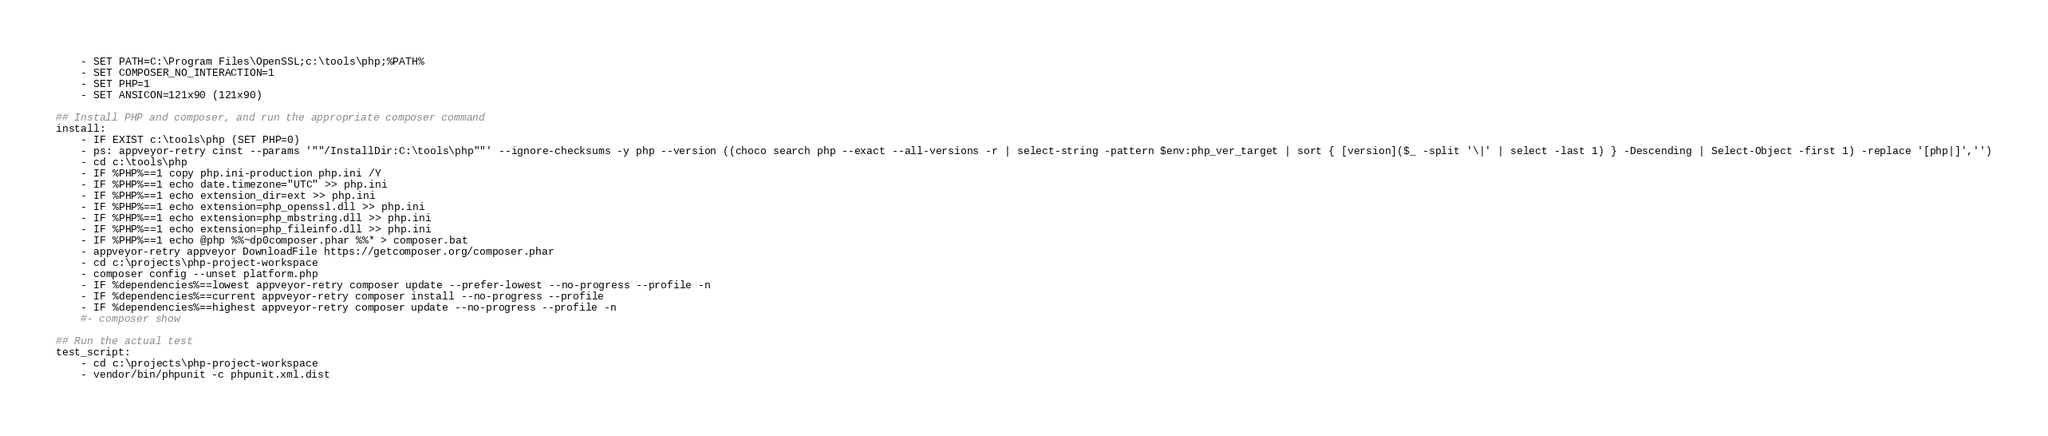Convert code to text. <code><loc_0><loc_0><loc_500><loc_500><_YAML_>    - SET PATH=C:\Program Files\OpenSSL;c:\tools\php;%PATH%
    - SET COMPOSER_NO_INTERACTION=1
    - SET PHP=1
    - SET ANSICON=121x90 (121x90)

## Install PHP and composer, and run the appropriate composer command
install:
    - IF EXIST c:\tools\php (SET PHP=0)
    - ps: appveyor-retry cinst --params '""/InstallDir:C:\tools\php""' --ignore-checksums -y php --version ((choco search php --exact --all-versions -r | select-string -pattern $env:php_ver_target | sort { [version]($_ -split '\|' | select -last 1) } -Descending | Select-Object -first 1) -replace '[php|]','')
    - cd c:\tools\php
    - IF %PHP%==1 copy php.ini-production php.ini /Y
    - IF %PHP%==1 echo date.timezone="UTC" >> php.ini
    - IF %PHP%==1 echo extension_dir=ext >> php.ini
    - IF %PHP%==1 echo extension=php_openssl.dll >> php.ini
    - IF %PHP%==1 echo extension=php_mbstring.dll >> php.ini
    - IF %PHP%==1 echo extension=php_fileinfo.dll >> php.ini
    - IF %PHP%==1 echo @php %%~dp0composer.phar %%* > composer.bat
    - appveyor-retry appveyor DownloadFile https://getcomposer.org/composer.phar
    - cd c:\projects\php-project-workspace
    - composer config --unset platform.php
    - IF %dependencies%==lowest appveyor-retry composer update --prefer-lowest --no-progress --profile -n
    - IF %dependencies%==current appveyor-retry composer install --no-progress --profile
    - IF %dependencies%==highest appveyor-retry composer update --no-progress --profile -n
    #- composer show

## Run the actual test
test_script:
    - cd c:\projects\php-project-workspace
    - vendor/bin/phpunit -c phpunit.xml.dist
</code> 